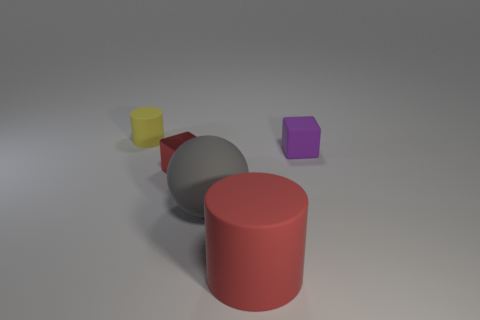Is the number of cubes that are to the right of the small red metallic cube the same as the number of green matte balls?
Ensure brevity in your answer.  No. What size is the cylinder that is behind the big gray matte thing?
Provide a short and direct response. Small. How many tiny metal objects are the same shape as the red rubber object?
Your answer should be very brief. 0. There is a tiny object that is in front of the tiny yellow matte cylinder and on the left side of the large cylinder; what material is it?
Ensure brevity in your answer.  Metal. Does the small red block have the same material as the red cylinder?
Ensure brevity in your answer.  No. What number of red metal blocks are there?
Your answer should be compact. 1. There is a matte cylinder to the left of the tiny shiny thing in front of the matte thing that is right of the red matte cylinder; what color is it?
Ensure brevity in your answer.  Yellow. Does the large cylinder have the same color as the small rubber block?
Make the answer very short. No. What number of cubes are to the left of the small matte cube and on the right side of the tiny red cube?
Keep it short and to the point. 0. What number of matte objects are either large gray objects or small red objects?
Your answer should be very brief. 1. 